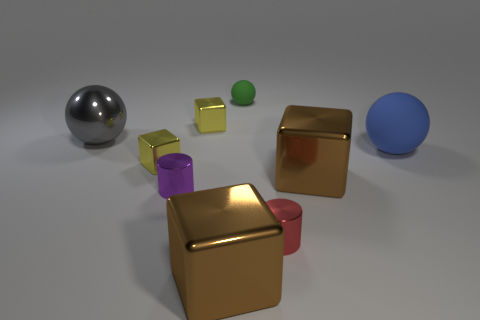How many objects are either small things on the right side of the green matte sphere or small shiny cubes?
Provide a succinct answer. 3. There is a brown metallic block on the left side of the small red cylinder; what is its size?
Offer a very short reply. Large. Is there a blue sphere of the same size as the gray sphere?
Offer a very short reply. Yes. There is a brown metal cube to the left of the green sphere; is it the same size as the tiny green ball?
Make the answer very short. No. How big is the blue matte sphere?
Make the answer very short. Large. There is a small shiny cube that is on the left side of the tiny yellow metal cube behind the tiny yellow metal block left of the purple cylinder; what is its color?
Make the answer very short. Yellow. What number of big things are both to the right of the big gray sphere and to the left of the blue rubber object?
Give a very brief answer. 2. What size is the green object that is the same shape as the large blue rubber thing?
Make the answer very short. Small. How many yellow things are in front of the yellow metal thing behind the ball that is to the right of the red thing?
Provide a succinct answer. 1. What color is the metal cylinder in front of the tiny metal cylinder to the left of the tiny matte ball?
Keep it short and to the point. Red. 